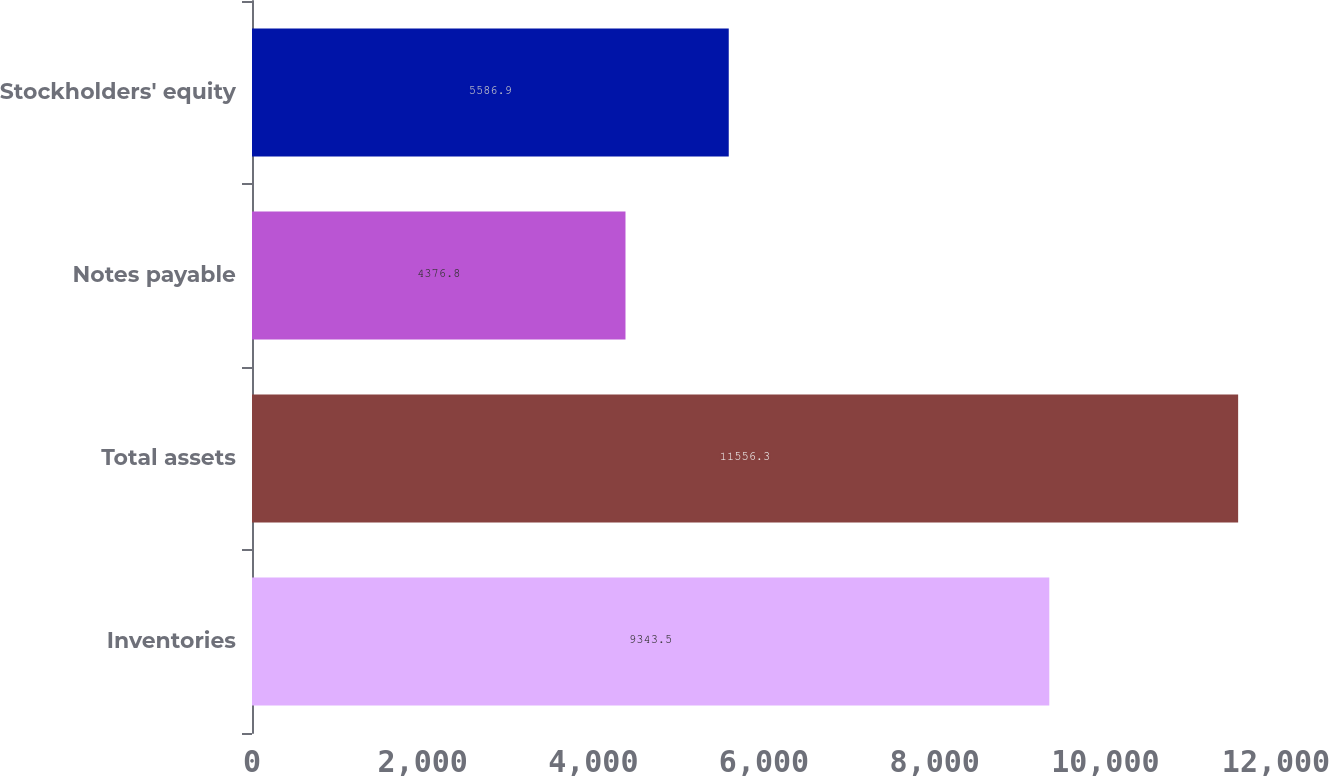Convert chart. <chart><loc_0><loc_0><loc_500><loc_500><bar_chart><fcel>Inventories<fcel>Total assets<fcel>Notes payable<fcel>Stockholders' equity<nl><fcel>9343.5<fcel>11556.3<fcel>4376.8<fcel>5586.9<nl></chart> 